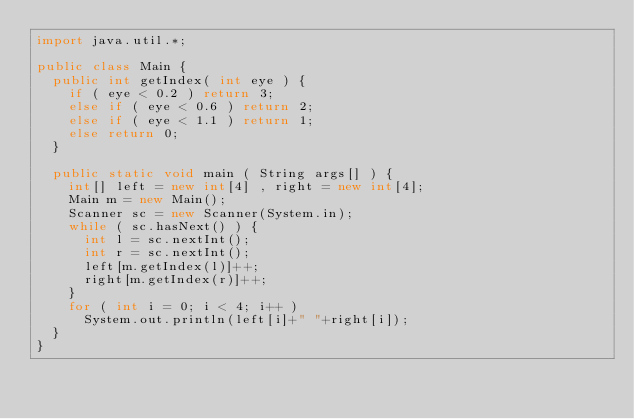Convert code to text. <code><loc_0><loc_0><loc_500><loc_500><_Java_>import java.util.*;

public class Main {
	public int getIndex( int eye ) {
		if ( eye < 0.2 ) return 3;
		else if ( eye < 0.6 ) return 2;
		else if ( eye < 1.1 ) return 1;
		else return 0;
	}
	
	public static void main ( String args[] ) {
		int[] left = new int[4] , right = new int[4];
		Main m = new Main();
		Scanner sc = new Scanner(System.in);
		while ( sc.hasNext() ) {
			int l = sc.nextInt();
			int r = sc.nextInt();
			left[m.getIndex(l)]++;
			right[m.getIndex(r)]++;
		}
		for ( int i = 0; i < 4; i++ )
			System.out.println(left[i]+" "+right[i]);
	}
}</code> 